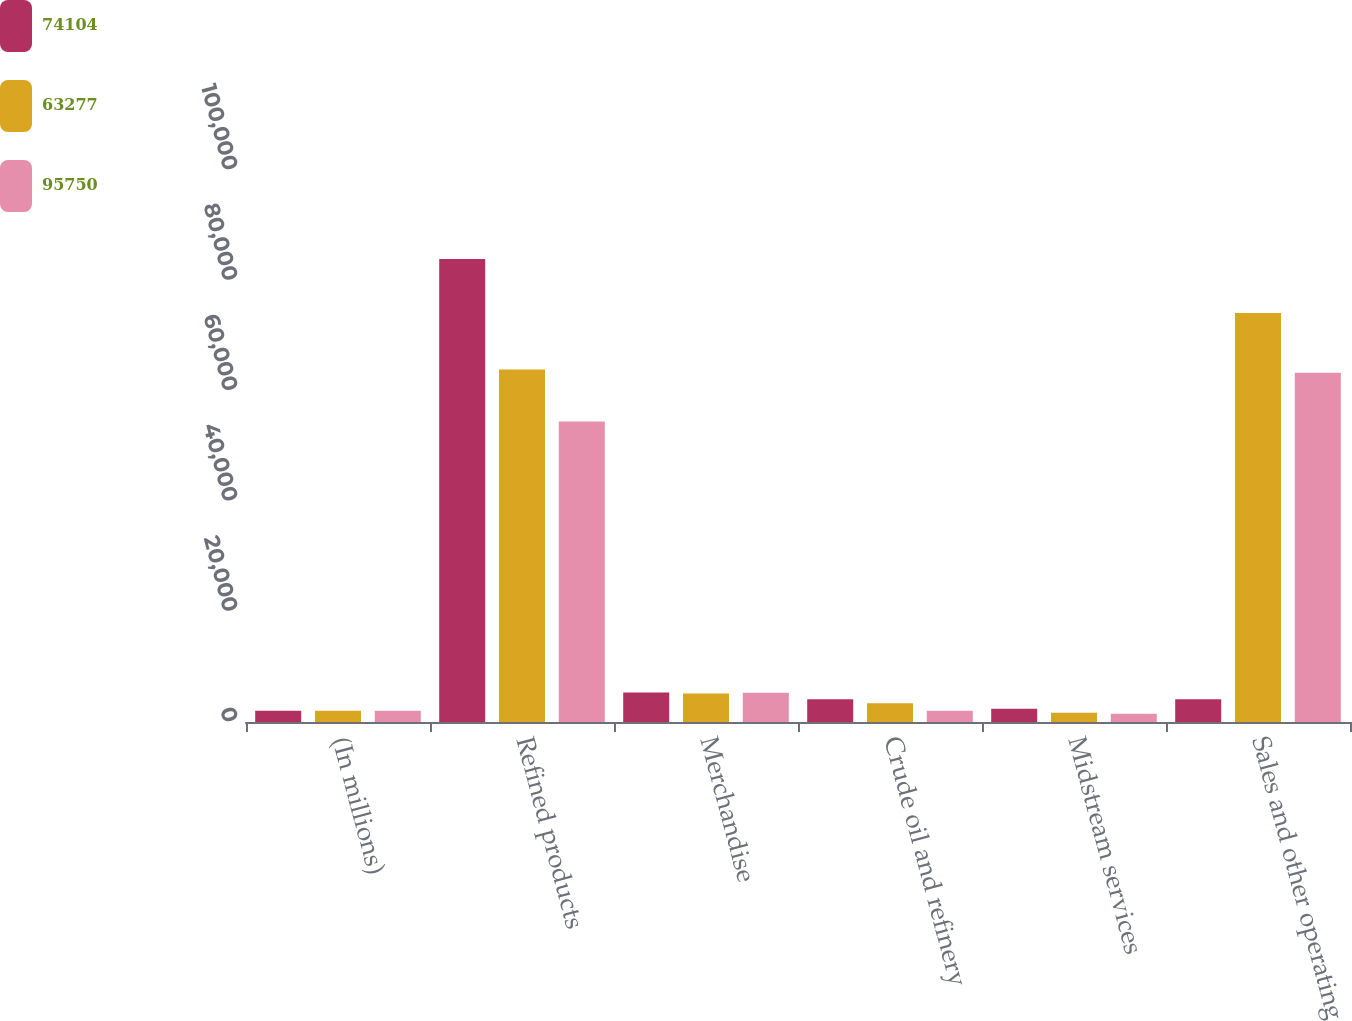Convert chart. <chart><loc_0><loc_0><loc_500><loc_500><stacked_bar_chart><ecel><fcel>(In millions)<fcel>Refined products<fcel>Merchandise<fcel>Crude oil and refinery<fcel>Midstream services<fcel>Sales and other operating<nl><fcel>74104<fcel>2018<fcel>83888<fcel>5332<fcel>4143<fcel>2387<fcel>4143<nl><fcel>63277<fcel>2017<fcel>63846<fcel>5174<fcel>3403<fcel>1681<fcel>74104<nl><fcel>95750<fcel>2016<fcel>54450<fcel>5297<fcel>2038<fcel>1492<fcel>63277<nl></chart> 